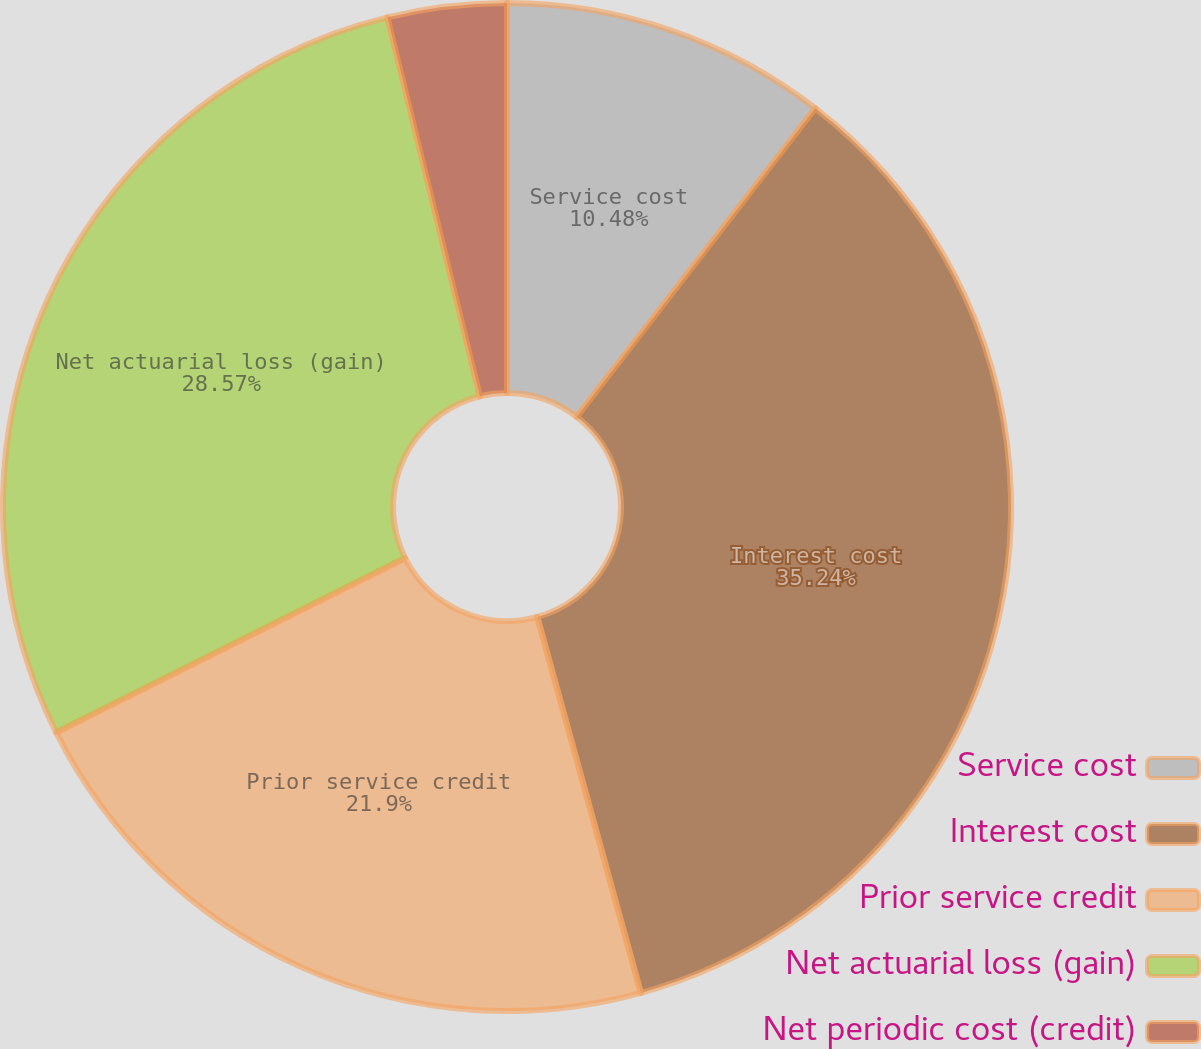<chart> <loc_0><loc_0><loc_500><loc_500><pie_chart><fcel>Service cost<fcel>Interest cost<fcel>Prior service credit<fcel>Net actuarial loss (gain)<fcel>Net periodic cost (credit)<nl><fcel>10.48%<fcel>35.24%<fcel>21.9%<fcel>28.57%<fcel>3.81%<nl></chart> 